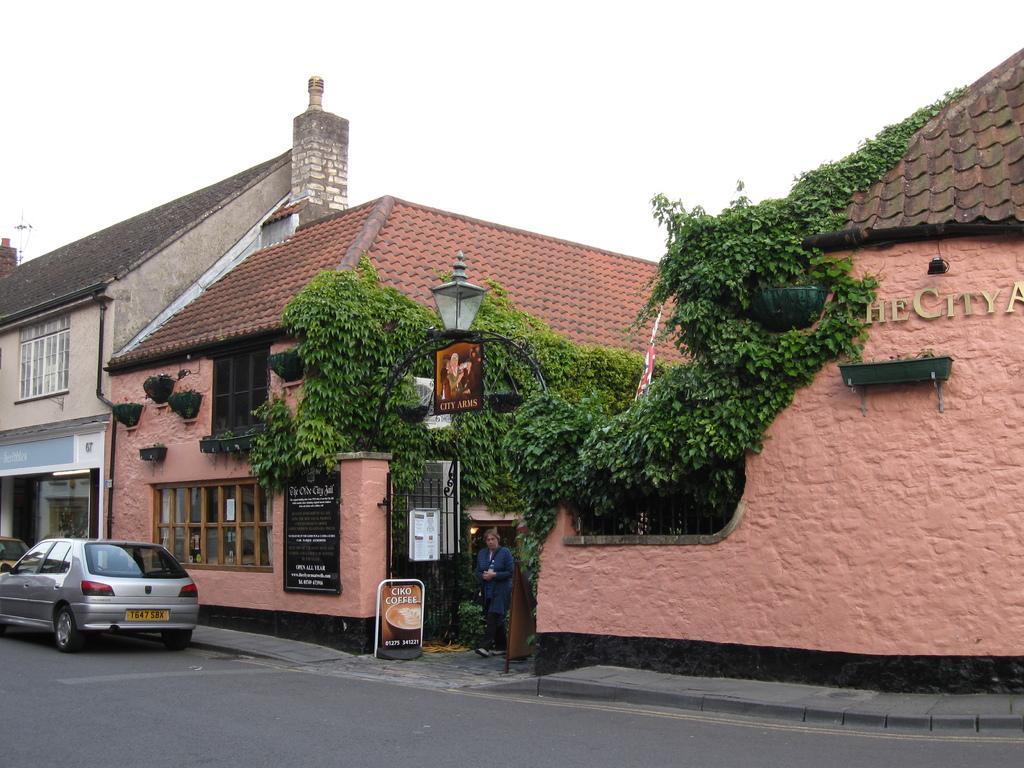Can you describe this image briefly? In the foreground, I can see buildings, boards, creepers, houseplants and vehicles on the road. In the background, I can see the sky. This picture might be taken in a day. 